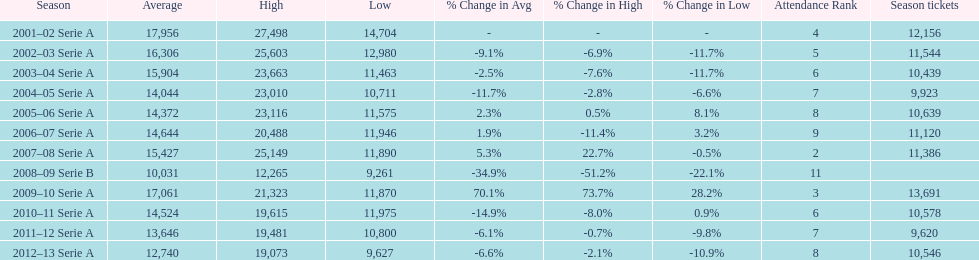How many seasons had average attendance of at least 15,000 at the stadio ennio tardini? 5. 